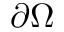Convert formula to latex. <formula><loc_0><loc_0><loc_500><loc_500>\partial \Omega</formula> 